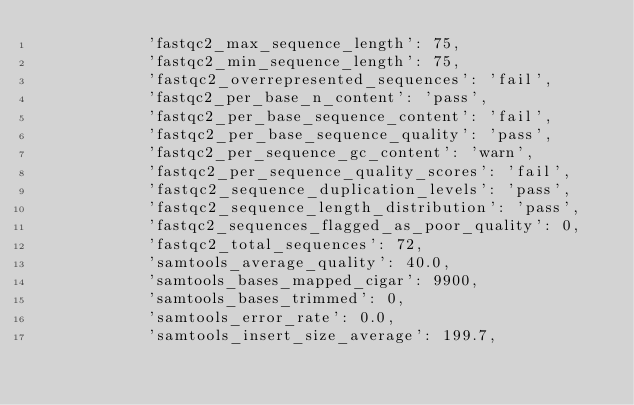Convert code to text. <code><loc_0><loc_0><loc_500><loc_500><_Python_>            'fastqc2_max_sequence_length': 75,
            'fastqc2_min_sequence_length': 75,
            'fastqc2_overrepresented_sequences': 'fail',
            'fastqc2_per_base_n_content': 'pass',
            'fastqc2_per_base_sequence_content': 'fail',
            'fastqc2_per_base_sequence_quality': 'pass',
            'fastqc2_per_sequence_gc_content': 'warn',
            'fastqc2_per_sequence_quality_scores': 'fail',
            'fastqc2_sequence_duplication_levels': 'pass',
            'fastqc2_sequence_length_distribution': 'pass',
            'fastqc2_sequences_flagged_as_poor_quality': 0,
            'fastqc2_total_sequences': 72,
            'samtools_average_quality': 40.0,
            'samtools_bases_mapped_cigar': 9900,
            'samtools_bases_trimmed': 0,
            'samtools_error_rate': 0.0,
            'samtools_insert_size_average': 199.7,</code> 